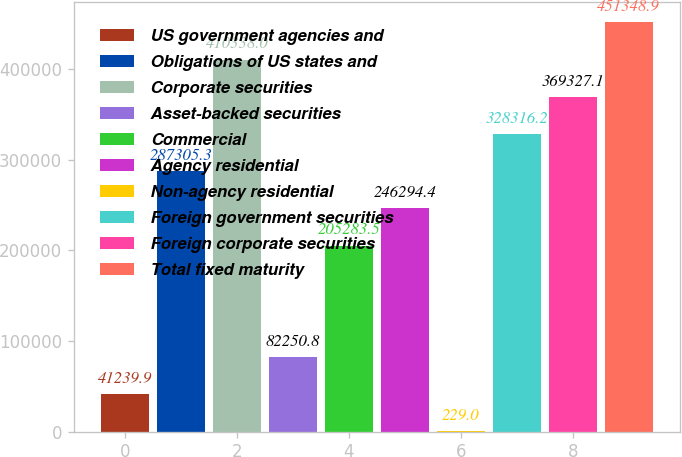Convert chart. <chart><loc_0><loc_0><loc_500><loc_500><bar_chart><fcel>US government agencies and<fcel>Obligations of US states and<fcel>Corporate securities<fcel>Asset-backed securities<fcel>Commercial<fcel>Agency residential<fcel>Non-agency residential<fcel>Foreign government securities<fcel>Foreign corporate securities<fcel>Total fixed maturity<nl><fcel>41239.9<fcel>287305<fcel>410338<fcel>82250.8<fcel>205284<fcel>246294<fcel>229<fcel>328316<fcel>369327<fcel>451349<nl></chart> 